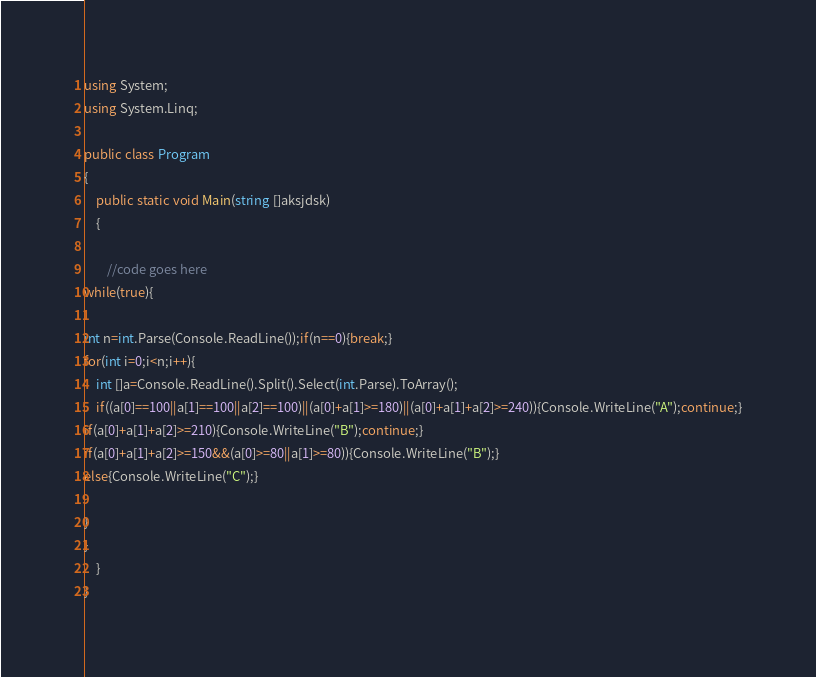Convert code to text. <code><loc_0><loc_0><loc_500><loc_500><_C#_>using System;
using System.Linq;

public class Program
{
	public static void Main(string []aksjdsk)
	{

		//code goes here
while(true){

int n=int.Parse(Console.ReadLine());if(n==0){break;}
for(int i=0;i<n;i++){
	int []a=Console.ReadLine().Split().Select(int.Parse).ToArray();
	if((a[0]==100||a[1]==100||a[2]==100)||(a[0]+a[1]>=180)||(a[0]+a[1]+a[2]>=240)){Console.WriteLine("A");continue;}
if(a[0]+a[1]+a[2]>=210){Console.WriteLine("B");continue;}
if(a[0]+a[1]+a[2]>=150&&(a[0]>=80||a[1]>=80)){Console.WriteLine("B");}
else{Console.WriteLine("C");}
	
}
}
	}
}</code> 